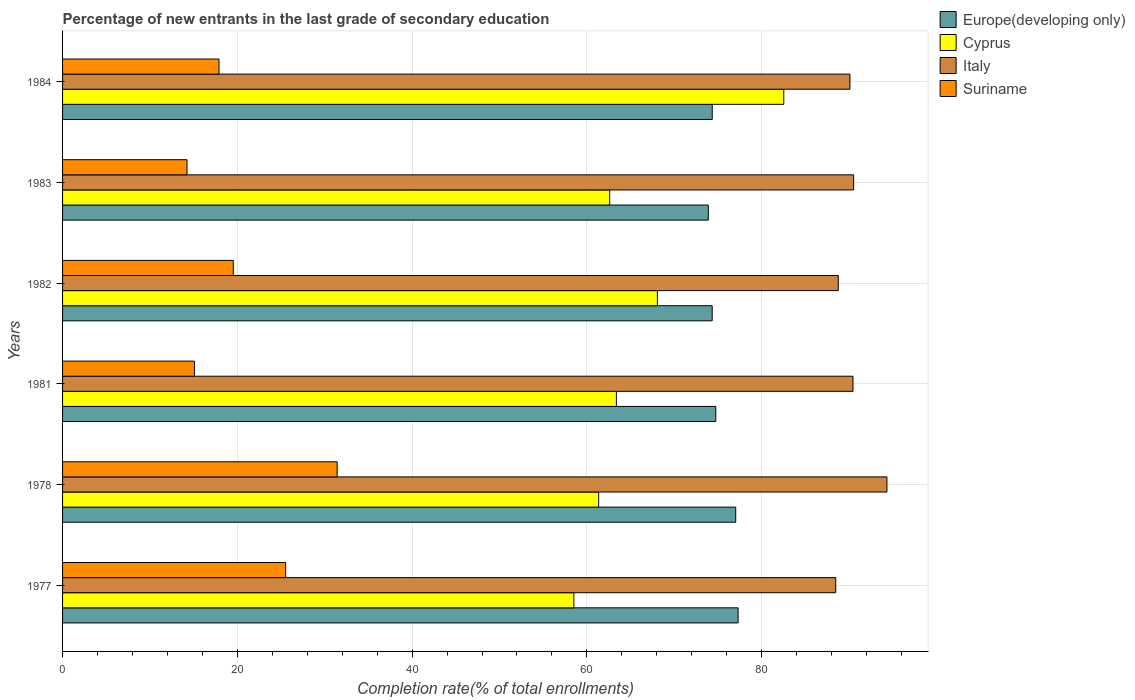How many groups of bars are there?
Make the answer very short. 6. How many bars are there on the 1st tick from the bottom?
Offer a terse response. 4. What is the label of the 1st group of bars from the top?
Keep it short and to the point. 1984. In how many cases, is the number of bars for a given year not equal to the number of legend labels?
Provide a succinct answer. 0. What is the percentage of new entrants in Cyprus in 1983?
Provide a short and direct response. 62.61. Across all years, what is the maximum percentage of new entrants in Italy?
Your answer should be compact. 94.33. Across all years, what is the minimum percentage of new entrants in Italy?
Keep it short and to the point. 88.47. In which year was the percentage of new entrants in Suriname maximum?
Offer a very short reply. 1978. What is the total percentage of new entrants in Suriname in the graph?
Provide a short and direct response. 123.72. What is the difference between the percentage of new entrants in Europe(developing only) in 1978 and that in 1984?
Give a very brief answer. 2.69. What is the difference between the percentage of new entrants in Cyprus in 1981 and the percentage of new entrants in Suriname in 1984?
Keep it short and to the point. 45.47. What is the average percentage of new entrants in Europe(developing only) per year?
Ensure brevity in your answer.  75.28. In the year 1978, what is the difference between the percentage of new entrants in Suriname and percentage of new entrants in Europe(developing only)?
Your response must be concise. -45.61. What is the ratio of the percentage of new entrants in Cyprus in 1983 to that in 1984?
Provide a succinct answer. 0.76. Is the difference between the percentage of new entrants in Suriname in 1978 and 1981 greater than the difference between the percentage of new entrants in Europe(developing only) in 1978 and 1981?
Ensure brevity in your answer.  Yes. What is the difference between the highest and the second highest percentage of new entrants in Europe(developing only)?
Offer a very short reply. 0.27. What is the difference between the highest and the lowest percentage of new entrants in Europe(developing only)?
Ensure brevity in your answer.  3.41. In how many years, is the percentage of new entrants in Italy greater than the average percentage of new entrants in Italy taken over all years?
Provide a succinct answer. 3. Is it the case that in every year, the sum of the percentage of new entrants in Suriname and percentage of new entrants in Cyprus is greater than the sum of percentage of new entrants in Europe(developing only) and percentage of new entrants in Italy?
Make the answer very short. No. What does the 2nd bar from the top in 1981 represents?
Give a very brief answer. Italy. What does the 2nd bar from the bottom in 1982 represents?
Your response must be concise. Cyprus. Is it the case that in every year, the sum of the percentage of new entrants in Italy and percentage of new entrants in Cyprus is greater than the percentage of new entrants in Europe(developing only)?
Your answer should be very brief. Yes. Are all the bars in the graph horizontal?
Offer a terse response. Yes. How many years are there in the graph?
Make the answer very short. 6. What is the difference between two consecutive major ticks on the X-axis?
Give a very brief answer. 20. How many legend labels are there?
Your response must be concise. 4. What is the title of the graph?
Make the answer very short. Percentage of new entrants in the last grade of secondary education. Does "Nicaragua" appear as one of the legend labels in the graph?
Offer a terse response. No. What is the label or title of the X-axis?
Give a very brief answer. Completion rate(% of total enrollments). What is the Completion rate(% of total enrollments) of Europe(developing only) in 1977?
Offer a very short reply. 77.3. What is the Completion rate(% of total enrollments) in Cyprus in 1977?
Give a very brief answer. 58.51. What is the Completion rate(% of total enrollments) in Italy in 1977?
Provide a short and direct response. 88.47. What is the Completion rate(% of total enrollments) of Suriname in 1977?
Your response must be concise. 25.53. What is the Completion rate(% of total enrollments) in Europe(developing only) in 1978?
Offer a very short reply. 77.03. What is the Completion rate(% of total enrollments) of Cyprus in 1978?
Your response must be concise. 61.35. What is the Completion rate(% of total enrollments) of Italy in 1978?
Your answer should be very brief. 94.33. What is the Completion rate(% of total enrollments) of Suriname in 1978?
Your response must be concise. 31.42. What is the Completion rate(% of total enrollments) of Europe(developing only) in 1981?
Your response must be concise. 74.75. What is the Completion rate(% of total enrollments) of Cyprus in 1981?
Make the answer very short. 63.38. What is the Completion rate(% of total enrollments) in Italy in 1981?
Provide a short and direct response. 90.45. What is the Completion rate(% of total enrollments) in Suriname in 1981?
Keep it short and to the point. 15.09. What is the Completion rate(% of total enrollments) in Europe(developing only) in 1982?
Your answer should be very brief. 74.34. What is the Completion rate(% of total enrollments) of Cyprus in 1982?
Make the answer very short. 68.07. What is the Completion rate(% of total enrollments) of Italy in 1982?
Provide a succinct answer. 88.76. What is the Completion rate(% of total enrollments) of Suriname in 1982?
Provide a short and direct response. 19.54. What is the Completion rate(% of total enrollments) in Europe(developing only) in 1983?
Your response must be concise. 73.89. What is the Completion rate(% of total enrollments) of Cyprus in 1983?
Your response must be concise. 62.61. What is the Completion rate(% of total enrollments) of Italy in 1983?
Provide a short and direct response. 90.52. What is the Completion rate(% of total enrollments) of Suriname in 1983?
Offer a terse response. 14.24. What is the Completion rate(% of total enrollments) in Europe(developing only) in 1984?
Keep it short and to the point. 74.34. What is the Completion rate(% of total enrollments) of Cyprus in 1984?
Provide a succinct answer. 82.53. What is the Completion rate(% of total enrollments) of Italy in 1984?
Offer a very short reply. 90.1. What is the Completion rate(% of total enrollments) of Suriname in 1984?
Offer a terse response. 17.9. Across all years, what is the maximum Completion rate(% of total enrollments) of Europe(developing only)?
Your response must be concise. 77.3. Across all years, what is the maximum Completion rate(% of total enrollments) in Cyprus?
Provide a succinct answer. 82.53. Across all years, what is the maximum Completion rate(% of total enrollments) in Italy?
Offer a very short reply. 94.33. Across all years, what is the maximum Completion rate(% of total enrollments) of Suriname?
Your answer should be very brief. 31.42. Across all years, what is the minimum Completion rate(% of total enrollments) in Europe(developing only)?
Ensure brevity in your answer.  73.89. Across all years, what is the minimum Completion rate(% of total enrollments) of Cyprus?
Your answer should be very brief. 58.51. Across all years, what is the minimum Completion rate(% of total enrollments) of Italy?
Provide a short and direct response. 88.47. Across all years, what is the minimum Completion rate(% of total enrollments) in Suriname?
Give a very brief answer. 14.24. What is the total Completion rate(% of total enrollments) of Europe(developing only) in the graph?
Give a very brief answer. 451.66. What is the total Completion rate(% of total enrollments) in Cyprus in the graph?
Ensure brevity in your answer.  396.43. What is the total Completion rate(% of total enrollments) in Italy in the graph?
Provide a succinct answer. 542.64. What is the total Completion rate(% of total enrollments) in Suriname in the graph?
Your answer should be compact. 123.72. What is the difference between the Completion rate(% of total enrollments) of Europe(developing only) in 1977 and that in 1978?
Offer a very short reply. 0.27. What is the difference between the Completion rate(% of total enrollments) of Cyprus in 1977 and that in 1978?
Your answer should be very brief. -2.84. What is the difference between the Completion rate(% of total enrollments) of Italy in 1977 and that in 1978?
Offer a terse response. -5.86. What is the difference between the Completion rate(% of total enrollments) of Suriname in 1977 and that in 1978?
Make the answer very short. -5.89. What is the difference between the Completion rate(% of total enrollments) in Europe(developing only) in 1977 and that in 1981?
Make the answer very short. 2.55. What is the difference between the Completion rate(% of total enrollments) of Cyprus in 1977 and that in 1981?
Provide a succinct answer. -4.87. What is the difference between the Completion rate(% of total enrollments) of Italy in 1977 and that in 1981?
Your answer should be very brief. -1.97. What is the difference between the Completion rate(% of total enrollments) of Suriname in 1977 and that in 1981?
Offer a terse response. 10.44. What is the difference between the Completion rate(% of total enrollments) in Europe(developing only) in 1977 and that in 1982?
Offer a very short reply. 2.97. What is the difference between the Completion rate(% of total enrollments) in Cyprus in 1977 and that in 1982?
Provide a succinct answer. -9.56. What is the difference between the Completion rate(% of total enrollments) of Italy in 1977 and that in 1982?
Ensure brevity in your answer.  -0.29. What is the difference between the Completion rate(% of total enrollments) in Suriname in 1977 and that in 1982?
Your answer should be very brief. 5.99. What is the difference between the Completion rate(% of total enrollments) in Europe(developing only) in 1977 and that in 1983?
Offer a terse response. 3.41. What is the difference between the Completion rate(% of total enrollments) in Cyprus in 1977 and that in 1983?
Your response must be concise. -4.1. What is the difference between the Completion rate(% of total enrollments) of Italy in 1977 and that in 1983?
Give a very brief answer. -2.05. What is the difference between the Completion rate(% of total enrollments) of Suriname in 1977 and that in 1983?
Provide a short and direct response. 11.29. What is the difference between the Completion rate(% of total enrollments) of Europe(developing only) in 1977 and that in 1984?
Provide a succinct answer. 2.96. What is the difference between the Completion rate(% of total enrollments) of Cyprus in 1977 and that in 1984?
Offer a terse response. -24.02. What is the difference between the Completion rate(% of total enrollments) of Italy in 1977 and that in 1984?
Give a very brief answer. -1.62. What is the difference between the Completion rate(% of total enrollments) of Suriname in 1977 and that in 1984?
Offer a very short reply. 7.63. What is the difference between the Completion rate(% of total enrollments) in Europe(developing only) in 1978 and that in 1981?
Make the answer very short. 2.28. What is the difference between the Completion rate(% of total enrollments) of Cyprus in 1978 and that in 1981?
Your answer should be compact. -2.03. What is the difference between the Completion rate(% of total enrollments) in Italy in 1978 and that in 1981?
Ensure brevity in your answer.  3.88. What is the difference between the Completion rate(% of total enrollments) in Suriname in 1978 and that in 1981?
Your answer should be very brief. 16.33. What is the difference between the Completion rate(% of total enrollments) in Europe(developing only) in 1978 and that in 1982?
Provide a succinct answer. 2.69. What is the difference between the Completion rate(% of total enrollments) in Cyprus in 1978 and that in 1982?
Your answer should be compact. -6.72. What is the difference between the Completion rate(% of total enrollments) in Italy in 1978 and that in 1982?
Give a very brief answer. 5.57. What is the difference between the Completion rate(% of total enrollments) in Suriname in 1978 and that in 1982?
Provide a succinct answer. 11.88. What is the difference between the Completion rate(% of total enrollments) of Europe(developing only) in 1978 and that in 1983?
Your answer should be compact. 3.14. What is the difference between the Completion rate(% of total enrollments) of Cyprus in 1978 and that in 1983?
Provide a succinct answer. -1.26. What is the difference between the Completion rate(% of total enrollments) of Italy in 1978 and that in 1983?
Provide a short and direct response. 3.81. What is the difference between the Completion rate(% of total enrollments) of Suriname in 1978 and that in 1983?
Provide a succinct answer. 17.18. What is the difference between the Completion rate(% of total enrollments) in Europe(developing only) in 1978 and that in 1984?
Give a very brief answer. 2.69. What is the difference between the Completion rate(% of total enrollments) of Cyprus in 1978 and that in 1984?
Offer a terse response. -21.18. What is the difference between the Completion rate(% of total enrollments) in Italy in 1978 and that in 1984?
Offer a very short reply. 4.23. What is the difference between the Completion rate(% of total enrollments) of Suriname in 1978 and that in 1984?
Make the answer very short. 13.52. What is the difference between the Completion rate(% of total enrollments) in Europe(developing only) in 1981 and that in 1982?
Provide a succinct answer. 0.41. What is the difference between the Completion rate(% of total enrollments) in Cyprus in 1981 and that in 1982?
Provide a short and direct response. -4.69. What is the difference between the Completion rate(% of total enrollments) in Italy in 1981 and that in 1982?
Your answer should be compact. 1.68. What is the difference between the Completion rate(% of total enrollments) in Suriname in 1981 and that in 1982?
Make the answer very short. -4.45. What is the difference between the Completion rate(% of total enrollments) in Europe(developing only) in 1981 and that in 1983?
Ensure brevity in your answer.  0.86. What is the difference between the Completion rate(% of total enrollments) of Cyprus in 1981 and that in 1983?
Ensure brevity in your answer.  0.77. What is the difference between the Completion rate(% of total enrollments) of Italy in 1981 and that in 1983?
Ensure brevity in your answer.  -0.07. What is the difference between the Completion rate(% of total enrollments) of Suriname in 1981 and that in 1983?
Offer a terse response. 0.85. What is the difference between the Completion rate(% of total enrollments) in Europe(developing only) in 1981 and that in 1984?
Make the answer very short. 0.41. What is the difference between the Completion rate(% of total enrollments) in Cyprus in 1981 and that in 1984?
Offer a very short reply. -19.16. What is the difference between the Completion rate(% of total enrollments) in Italy in 1981 and that in 1984?
Offer a very short reply. 0.35. What is the difference between the Completion rate(% of total enrollments) of Suriname in 1981 and that in 1984?
Ensure brevity in your answer.  -2.81. What is the difference between the Completion rate(% of total enrollments) in Europe(developing only) in 1982 and that in 1983?
Give a very brief answer. 0.44. What is the difference between the Completion rate(% of total enrollments) in Cyprus in 1982 and that in 1983?
Offer a terse response. 5.46. What is the difference between the Completion rate(% of total enrollments) in Italy in 1982 and that in 1983?
Your answer should be very brief. -1.76. What is the difference between the Completion rate(% of total enrollments) of Suriname in 1982 and that in 1983?
Give a very brief answer. 5.3. What is the difference between the Completion rate(% of total enrollments) in Europe(developing only) in 1982 and that in 1984?
Ensure brevity in your answer.  -0.01. What is the difference between the Completion rate(% of total enrollments) of Cyprus in 1982 and that in 1984?
Your response must be concise. -14.46. What is the difference between the Completion rate(% of total enrollments) in Italy in 1982 and that in 1984?
Provide a succinct answer. -1.33. What is the difference between the Completion rate(% of total enrollments) in Suriname in 1982 and that in 1984?
Provide a short and direct response. 1.64. What is the difference between the Completion rate(% of total enrollments) of Europe(developing only) in 1983 and that in 1984?
Provide a succinct answer. -0.45. What is the difference between the Completion rate(% of total enrollments) of Cyprus in 1983 and that in 1984?
Give a very brief answer. -19.92. What is the difference between the Completion rate(% of total enrollments) in Italy in 1983 and that in 1984?
Make the answer very short. 0.42. What is the difference between the Completion rate(% of total enrollments) in Suriname in 1983 and that in 1984?
Your answer should be very brief. -3.66. What is the difference between the Completion rate(% of total enrollments) of Europe(developing only) in 1977 and the Completion rate(% of total enrollments) of Cyprus in 1978?
Provide a succinct answer. 15.96. What is the difference between the Completion rate(% of total enrollments) of Europe(developing only) in 1977 and the Completion rate(% of total enrollments) of Italy in 1978?
Make the answer very short. -17.03. What is the difference between the Completion rate(% of total enrollments) in Europe(developing only) in 1977 and the Completion rate(% of total enrollments) in Suriname in 1978?
Your response must be concise. 45.88. What is the difference between the Completion rate(% of total enrollments) in Cyprus in 1977 and the Completion rate(% of total enrollments) in Italy in 1978?
Your answer should be very brief. -35.82. What is the difference between the Completion rate(% of total enrollments) in Cyprus in 1977 and the Completion rate(% of total enrollments) in Suriname in 1978?
Offer a very short reply. 27.09. What is the difference between the Completion rate(% of total enrollments) in Italy in 1977 and the Completion rate(% of total enrollments) in Suriname in 1978?
Provide a short and direct response. 57.05. What is the difference between the Completion rate(% of total enrollments) of Europe(developing only) in 1977 and the Completion rate(% of total enrollments) of Cyprus in 1981?
Your response must be concise. 13.93. What is the difference between the Completion rate(% of total enrollments) in Europe(developing only) in 1977 and the Completion rate(% of total enrollments) in Italy in 1981?
Make the answer very short. -13.15. What is the difference between the Completion rate(% of total enrollments) in Europe(developing only) in 1977 and the Completion rate(% of total enrollments) in Suriname in 1981?
Provide a succinct answer. 62.21. What is the difference between the Completion rate(% of total enrollments) of Cyprus in 1977 and the Completion rate(% of total enrollments) of Italy in 1981?
Your answer should be compact. -31.94. What is the difference between the Completion rate(% of total enrollments) of Cyprus in 1977 and the Completion rate(% of total enrollments) of Suriname in 1981?
Offer a very short reply. 43.42. What is the difference between the Completion rate(% of total enrollments) of Italy in 1977 and the Completion rate(% of total enrollments) of Suriname in 1981?
Your answer should be compact. 73.39. What is the difference between the Completion rate(% of total enrollments) in Europe(developing only) in 1977 and the Completion rate(% of total enrollments) in Cyprus in 1982?
Your response must be concise. 9.24. What is the difference between the Completion rate(% of total enrollments) in Europe(developing only) in 1977 and the Completion rate(% of total enrollments) in Italy in 1982?
Offer a terse response. -11.46. What is the difference between the Completion rate(% of total enrollments) of Europe(developing only) in 1977 and the Completion rate(% of total enrollments) of Suriname in 1982?
Ensure brevity in your answer.  57.76. What is the difference between the Completion rate(% of total enrollments) in Cyprus in 1977 and the Completion rate(% of total enrollments) in Italy in 1982?
Offer a very short reply. -30.26. What is the difference between the Completion rate(% of total enrollments) in Cyprus in 1977 and the Completion rate(% of total enrollments) in Suriname in 1982?
Provide a succinct answer. 38.97. What is the difference between the Completion rate(% of total enrollments) of Italy in 1977 and the Completion rate(% of total enrollments) of Suriname in 1982?
Ensure brevity in your answer.  68.94. What is the difference between the Completion rate(% of total enrollments) in Europe(developing only) in 1977 and the Completion rate(% of total enrollments) in Cyprus in 1983?
Make the answer very short. 14.69. What is the difference between the Completion rate(% of total enrollments) in Europe(developing only) in 1977 and the Completion rate(% of total enrollments) in Italy in 1983?
Your answer should be compact. -13.22. What is the difference between the Completion rate(% of total enrollments) of Europe(developing only) in 1977 and the Completion rate(% of total enrollments) of Suriname in 1983?
Give a very brief answer. 63.06. What is the difference between the Completion rate(% of total enrollments) of Cyprus in 1977 and the Completion rate(% of total enrollments) of Italy in 1983?
Your answer should be very brief. -32.02. What is the difference between the Completion rate(% of total enrollments) of Cyprus in 1977 and the Completion rate(% of total enrollments) of Suriname in 1983?
Offer a terse response. 44.27. What is the difference between the Completion rate(% of total enrollments) in Italy in 1977 and the Completion rate(% of total enrollments) in Suriname in 1983?
Your answer should be very brief. 74.23. What is the difference between the Completion rate(% of total enrollments) in Europe(developing only) in 1977 and the Completion rate(% of total enrollments) in Cyprus in 1984?
Your answer should be very brief. -5.23. What is the difference between the Completion rate(% of total enrollments) of Europe(developing only) in 1977 and the Completion rate(% of total enrollments) of Italy in 1984?
Make the answer very short. -12.8. What is the difference between the Completion rate(% of total enrollments) in Europe(developing only) in 1977 and the Completion rate(% of total enrollments) in Suriname in 1984?
Offer a very short reply. 59.4. What is the difference between the Completion rate(% of total enrollments) in Cyprus in 1977 and the Completion rate(% of total enrollments) in Italy in 1984?
Provide a short and direct response. -31.59. What is the difference between the Completion rate(% of total enrollments) of Cyprus in 1977 and the Completion rate(% of total enrollments) of Suriname in 1984?
Give a very brief answer. 40.61. What is the difference between the Completion rate(% of total enrollments) of Italy in 1977 and the Completion rate(% of total enrollments) of Suriname in 1984?
Offer a terse response. 70.57. What is the difference between the Completion rate(% of total enrollments) in Europe(developing only) in 1978 and the Completion rate(% of total enrollments) in Cyprus in 1981?
Keep it short and to the point. 13.66. What is the difference between the Completion rate(% of total enrollments) of Europe(developing only) in 1978 and the Completion rate(% of total enrollments) of Italy in 1981?
Offer a very short reply. -13.42. What is the difference between the Completion rate(% of total enrollments) in Europe(developing only) in 1978 and the Completion rate(% of total enrollments) in Suriname in 1981?
Offer a terse response. 61.94. What is the difference between the Completion rate(% of total enrollments) in Cyprus in 1978 and the Completion rate(% of total enrollments) in Italy in 1981?
Provide a succinct answer. -29.1. What is the difference between the Completion rate(% of total enrollments) in Cyprus in 1978 and the Completion rate(% of total enrollments) in Suriname in 1981?
Your answer should be very brief. 46.26. What is the difference between the Completion rate(% of total enrollments) of Italy in 1978 and the Completion rate(% of total enrollments) of Suriname in 1981?
Your answer should be very brief. 79.24. What is the difference between the Completion rate(% of total enrollments) in Europe(developing only) in 1978 and the Completion rate(% of total enrollments) in Cyprus in 1982?
Provide a short and direct response. 8.96. What is the difference between the Completion rate(% of total enrollments) of Europe(developing only) in 1978 and the Completion rate(% of total enrollments) of Italy in 1982?
Provide a short and direct response. -11.73. What is the difference between the Completion rate(% of total enrollments) in Europe(developing only) in 1978 and the Completion rate(% of total enrollments) in Suriname in 1982?
Provide a short and direct response. 57.49. What is the difference between the Completion rate(% of total enrollments) of Cyprus in 1978 and the Completion rate(% of total enrollments) of Italy in 1982?
Provide a succinct answer. -27.42. What is the difference between the Completion rate(% of total enrollments) in Cyprus in 1978 and the Completion rate(% of total enrollments) in Suriname in 1982?
Keep it short and to the point. 41.81. What is the difference between the Completion rate(% of total enrollments) in Italy in 1978 and the Completion rate(% of total enrollments) in Suriname in 1982?
Make the answer very short. 74.79. What is the difference between the Completion rate(% of total enrollments) in Europe(developing only) in 1978 and the Completion rate(% of total enrollments) in Cyprus in 1983?
Ensure brevity in your answer.  14.42. What is the difference between the Completion rate(% of total enrollments) in Europe(developing only) in 1978 and the Completion rate(% of total enrollments) in Italy in 1983?
Provide a short and direct response. -13.49. What is the difference between the Completion rate(% of total enrollments) of Europe(developing only) in 1978 and the Completion rate(% of total enrollments) of Suriname in 1983?
Ensure brevity in your answer.  62.79. What is the difference between the Completion rate(% of total enrollments) of Cyprus in 1978 and the Completion rate(% of total enrollments) of Italy in 1983?
Keep it short and to the point. -29.18. What is the difference between the Completion rate(% of total enrollments) in Cyprus in 1978 and the Completion rate(% of total enrollments) in Suriname in 1983?
Your answer should be very brief. 47.1. What is the difference between the Completion rate(% of total enrollments) of Italy in 1978 and the Completion rate(% of total enrollments) of Suriname in 1983?
Your answer should be very brief. 80.09. What is the difference between the Completion rate(% of total enrollments) of Europe(developing only) in 1978 and the Completion rate(% of total enrollments) of Cyprus in 1984?
Give a very brief answer. -5.5. What is the difference between the Completion rate(% of total enrollments) of Europe(developing only) in 1978 and the Completion rate(% of total enrollments) of Italy in 1984?
Your answer should be very brief. -13.07. What is the difference between the Completion rate(% of total enrollments) of Europe(developing only) in 1978 and the Completion rate(% of total enrollments) of Suriname in 1984?
Give a very brief answer. 59.13. What is the difference between the Completion rate(% of total enrollments) in Cyprus in 1978 and the Completion rate(% of total enrollments) in Italy in 1984?
Provide a succinct answer. -28.75. What is the difference between the Completion rate(% of total enrollments) of Cyprus in 1978 and the Completion rate(% of total enrollments) of Suriname in 1984?
Make the answer very short. 43.44. What is the difference between the Completion rate(% of total enrollments) of Italy in 1978 and the Completion rate(% of total enrollments) of Suriname in 1984?
Your answer should be compact. 76.43. What is the difference between the Completion rate(% of total enrollments) of Europe(developing only) in 1981 and the Completion rate(% of total enrollments) of Cyprus in 1982?
Give a very brief answer. 6.68. What is the difference between the Completion rate(% of total enrollments) in Europe(developing only) in 1981 and the Completion rate(% of total enrollments) in Italy in 1982?
Give a very brief answer. -14.01. What is the difference between the Completion rate(% of total enrollments) in Europe(developing only) in 1981 and the Completion rate(% of total enrollments) in Suriname in 1982?
Offer a very short reply. 55.21. What is the difference between the Completion rate(% of total enrollments) of Cyprus in 1981 and the Completion rate(% of total enrollments) of Italy in 1982?
Provide a short and direct response. -25.39. What is the difference between the Completion rate(% of total enrollments) of Cyprus in 1981 and the Completion rate(% of total enrollments) of Suriname in 1982?
Your answer should be compact. 43.84. What is the difference between the Completion rate(% of total enrollments) of Italy in 1981 and the Completion rate(% of total enrollments) of Suriname in 1982?
Provide a short and direct response. 70.91. What is the difference between the Completion rate(% of total enrollments) in Europe(developing only) in 1981 and the Completion rate(% of total enrollments) in Cyprus in 1983?
Provide a succinct answer. 12.14. What is the difference between the Completion rate(% of total enrollments) of Europe(developing only) in 1981 and the Completion rate(% of total enrollments) of Italy in 1983?
Provide a short and direct response. -15.77. What is the difference between the Completion rate(% of total enrollments) in Europe(developing only) in 1981 and the Completion rate(% of total enrollments) in Suriname in 1983?
Provide a succinct answer. 60.51. What is the difference between the Completion rate(% of total enrollments) in Cyprus in 1981 and the Completion rate(% of total enrollments) in Italy in 1983?
Provide a short and direct response. -27.15. What is the difference between the Completion rate(% of total enrollments) in Cyprus in 1981 and the Completion rate(% of total enrollments) in Suriname in 1983?
Keep it short and to the point. 49.13. What is the difference between the Completion rate(% of total enrollments) in Italy in 1981 and the Completion rate(% of total enrollments) in Suriname in 1983?
Ensure brevity in your answer.  76.21. What is the difference between the Completion rate(% of total enrollments) in Europe(developing only) in 1981 and the Completion rate(% of total enrollments) in Cyprus in 1984?
Make the answer very short. -7.78. What is the difference between the Completion rate(% of total enrollments) in Europe(developing only) in 1981 and the Completion rate(% of total enrollments) in Italy in 1984?
Your response must be concise. -15.35. What is the difference between the Completion rate(% of total enrollments) in Europe(developing only) in 1981 and the Completion rate(% of total enrollments) in Suriname in 1984?
Your answer should be very brief. 56.85. What is the difference between the Completion rate(% of total enrollments) of Cyprus in 1981 and the Completion rate(% of total enrollments) of Italy in 1984?
Provide a succinct answer. -26.72. What is the difference between the Completion rate(% of total enrollments) of Cyprus in 1981 and the Completion rate(% of total enrollments) of Suriname in 1984?
Your answer should be very brief. 45.47. What is the difference between the Completion rate(% of total enrollments) in Italy in 1981 and the Completion rate(% of total enrollments) in Suriname in 1984?
Provide a succinct answer. 72.55. What is the difference between the Completion rate(% of total enrollments) of Europe(developing only) in 1982 and the Completion rate(% of total enrollments) of Cyprus in 1983?
Make the answer very short. 11.73. What is the difference between the Completion rate(% of total enrollments) of Europe(developing only) in 1982 and the Completion rate(% of total enrollments) of Italy in 1983?
Offer a very short reply. -16.19. What is the difference between the Completion rate(% of total enrollments) of Europe(developing only) in 1982 and the Completion rate(% of total enrollments) of Suriname in 1983?
Offer a terse response. 60.09. What is the difference between the Completion rate(% of total enrollments) in Cyprus in 1982 and the Completion rate(% of total enrollments) in Italy in 1983?
Provide a short and direct response. -22.46. What is the difference between the Completion rate(% of total enrollments) of Cyprus in 1982 and the Completion rate(% of total enrollments) of Suriname in 1983?
Make the answer very short. 53.82. What is the difference between the Completion rate(% of total enrollments) of Italy in 1982 and the Completion rate(% of total enrollments) of Suriname in 1983?
Provide a short and direct response. 74.52. What is the difference between the Completion rate(% of total enrollments) of Europe(developing only) in 1982 and the Completion rate(% of total enrollments) of Cyprus in 1984?
Your answer should be very brief. -8.19. What is the difference between the Completion rate(% of total enrollments) in Europe(developing only) in 1982 and the Completion rate(% of total enrollments) in Italy in 1984?
Ensure brevity in your answer.  -15.76. What is the difference between the Completion rate(% of total enrollments) in Europe(developing only) in 1982 and the Completion rate(% of total enrollments) in Suriname in 1984?
Your response must be concise. 56.43. What is the difference between the Completion rate(% of total enrollments) of Cyprus in 1982 and the Completion rate(% of total enrollments) of Italy in 1984?
Your response must be concise. -22.03. What is the difference between the Completion rate(% of total enrollments) of Cyprus in 1982 and the Completion rate(% of total enrollments) of Suriname in 1984?
Offer a terse response. 50.16. What is the difference between the Completion rate(% of total enrollments) in Italy in 1982 and the Completion rate(% of total enrollments) in Suriname in 1984?
Make the answer very short. 70.86. What is the difference between the Completion rate(% of total enrollments) of Europe(developing only) in 1983 and the Completion rate(% of total enrollments) of Cyprus in 1984?
Ensure brevity in your answer.  -8.64. What is the difference between the Completion rate(% of total enrollments) in Europe(developing only) in 1983 and the Completion rate(% of total enrollments) in Italy in 1984?
Your response must be concise. -16.21. What is the difference between the Completion rate(% of total enrollments) in Europe(developing only) in 1983 and the Completion rate(% of total enrollments) in Suriname in 1984?
Your response must be concise. 55.99. What is the difference between the Completion rate(% of total enrollments) in Cyprus in 1983 and the Completion rate(% of total enrollments) in Italy in 1984?
Keep it short and to the point. -27.49. What is the difference between the Completion rate(% of total enrollments) of Cyprus in 1983 and the Completion rate(% of total enrollments) of Suriname in 1984?
Your response must be concise. 44.71. What is the difference between the Completion rate(% of total enrollments) of Italy in 1983 and the Completion rate(% of total enrollments) of Suriname in 1984?
Your answer should be very brief. 72.62. What is the average Completion rate(% of total enrollments) of Europe(developing only) per year?
Your answer should be very brief. 75.28. What is the average Completion rate(% of total enrollments) of Cyprus per year?
Give a very brief answer. 66.07. What is the average Completion rate(% of total enrollments) of Italy per year?
Make the answer very short. 90.44. What is the average Completion rate(% of total enrollments) in Suriname per year?
Your response must be concise. 20.62. In the year 1977, what is the difference between the Completion rate(% of total enrollments) of Europe(developing only) and Completion rate(% of total enrollments) of Cyprus?
Give a very brief answer. 18.79. In the year 1977, what is the difference between the Completion rate(% of total enrollments) in Europe(developing only) and Completion rate(% of total enrollments) in Italy?
Ensure brevity in your answer.  -11.17. In the year 1977, what is the difference between the Completion rate(% of total enrollments) in Europe(developing only) and Completion rate(% of total enrollments) in Suriname?
Your response must be concise. 51.77. In the year 1977, what is the difference between the Completion rate(% of total enrollments) in Cyprus and Completion rate(% of total enrollments) in Italy?
Make the answer very short. -29.97. In the year 1977, what is the difference between the Completion rate(% of total enrollments) in Cyprus and Completion rate(% of total enrollments) in Suriname?
Offer a very short reply. 32.98. In the year 1977, what is the difference between the Completion rate(% of total enrollments) of Italy and Completion rate(% of total enrollments) of Suriname?
Offer a terse response. 62.95. In the year 1978, what is the difference between the Completion rate(% of total enrollments) in Europe(developing only) and Completion rate(% of total enrollments) in Cyprus?
Make the answer very short. 15.69. In the year 1978, what is the difference between the Completion rate(% of total enrollments) of Europe(developing only) and Completion rate(% of total enrollments) of Italy?
Your response must be concise. -17.3. In the year 1978, what is the difference between the Completion rate(% of total enrollments) in Europe(developing only) and Completion rate(% of total enrollments) in Suriname?
Give a very brief answer. 45.61. In the year 1978, what is the difference between the Completion rate(% of total enrollments) of Cyprus and Completion rate(% of total enrollments) of Italy?
Keep it short and to the point. -32.99. In the year 1978, what is the difference between the Completion rate(% of total enrollments) in Cyprus and Completion rate(% of total enrollments) in Suriname?
Keep it short and to the point. 29.92. In the year 1978, what is the difference between the Completion rate(% of total enrollments) of Italy and Completion rate(% of total enrollments) of Suriname?
Offer a very short reply. 62.91. In the year 1981, what is the difference between the Completion rate(% of total enrollments) in Europe(developing only) and Completion rate(% of total enrollments) in Cyprus?
Provide a short and direct response. 11.38. In the year 1981, what is the difference between the Completion rate(% of total enrollments) of Europe(developing only) and Completion rate(% of total enrollments) of Italy?
Make the answer very short. -15.7. In the year 1981, what is the difference between the Completion rate(% of total enrollments) of Europe(developing only) and Completion rate(% of total enrollments) of Suriname?
Make the answer very short. 59.66. In the year 1981, what is the difference between the Completion rate(% of total enrollments) in Cyprus and Completion rate(% of total enrollments) in Italy?
Your response must be concise. -27.07. In the year 1981, what is the difference between the Completion rate(% of total enrollments) of Cyprus and Completion rate(% of total enrollments) of Suriname?
Provide a succinct answer. 48.29. In the year 1981, what is the difference between the Completion rate(% of total enrollments) in Italy and Completion rate(% of total enrollments) in Suriname?
Provide a short and direct response. 75.36. In the year 1982, what is the difference between the Completion rate(% of total enrollments) of Europe(developing only) and Completion rate(% of total enrollments) of Cyprus?
Your response must be concise. 6.27. In the year 1982, what is the difference between the Completion rate(% of total enrollments) of Europe(developing only) and Completion rate(% of total enrollments) of Italy?
Give a very brief answer. -14.43. In the year 1982, what is the difference between the Completion rate(% of total enrollments) in Europe(developing only) and Completion rate(% of total enrollments) in Suriname?
Your answer should be very brief. 54.8. In the year 1982, what is the difference between the Completion rate(% of total enrollments) of Cyprus and Completion rate(% of total enrollments) of Italy?
Make the answer very short. -20.7. In the year 1982, what is the difference between the Completion rate(% of total enrollments) in Cyprus and Completion rate(% of total enrollments) in Suriname?
Your response must be concise. 48.53. In the year 1982, what is the difference between the Completion rate(% of total enrollments) of Italy and Completion rate(% of total enrollments) of Suriname?
Provide a short and direct response. 69.23. In the year 1983, what is the difference between the Completion rate(% of total enrollments) in Europe(developing only) and Completion rate(% of total enrollments) in Cyprus?
Offer a very short reply. 11.28. In the year 1983, what is the difference between the Completion rate(% of total enrollments) in Europe(developing only) and Completion rate(% of total enrollments) in Italy?
Your response must be concise. -16.63. In the year 1983, what is the difference between the Completion rate(% of total enrollments) in Europe(developing only) and Completion rate(% of total enrollments) in Suriname?
Your answer should be compact. 59.65. In the year 1983, what is the difference between the Completion rate(% of total enrollments) of Cyprus and Completion rate(% of total enrollments) of Italy?
Offer a very short reply. -27.91. In the year 1983, what is the difference between the Completion rate(% of total enrollments) in Cyprus and Completion rate(% of total enrollments) in Suriname?
Offer a terse response. 48.37. In the year 1983, what is the difference between the Completion rate(% of total enrollments) of Italy and Completion rate(% of total enrollments) of Suriname?
Offer a terse response. 76.28. In the year 1984, what is the difference between the Completion rate(% of total enrollments) in Europe(developing only) and Completion rate(% of total enrollments) in Cyprus?
Provide a succinct answer. -8.19. In the year 1984, what is the difference between the Completion rate(% of total enrollments) of Europe(developing only) and Completion rate(% of total enrollments) of Italy?
Provide a short and direct response. -15.76. In the year 1984, what is the difference between the Completion rate(% of total enrollments) in Europe(developing only) and Completion rate(% of total enrollments) in Suriname?
Offer a terse response. 56.44. In the year 1984, what is the difference between the Completion rate(% of total enrollments) in Cyprus and Completion rate(% of total enrollments) in Italy?
Make the answer very short. -7.57. In the year 1984, what is the difference between the Completion rate(% of total enrollments) of Cyprus and Completion rate(% of total enrollments) of Suriname?
Offer a terse response. 64.63. In the year 1984, what is the difference between the Completion rate(% of total enrollments) in Italy and Completion rate(% of total enrollments) in Suriname?
Ensure brevity in your answer.  72.2. What is the ratio of the Completion rate(% of total enrollments) in Europe(developing only) in 1977 to that in 1978?
Provide a short and direct response. 1. What is the ratio of the Completion rate(% of total enrollments) of Cyprus in 1977 to that in 1978?
Your response must be concise. 0.95. What is the ratio of the Completion rate(% of total enrollments) in Italy in 1977 to that in 1978?
Provide a succinct answer. 0.94. What is the ratio of the Completion rate(% of total enrollments) in Suriname in 1977 to that in 1978?
Provide a succinct answer. 0.81. What is the ratio of the Completion rate(% of total enrollments) of Europe(developing only) in 1977 to that in 1981?
Make the answer very short. 1.03. What is the ratio of the Completion rate(% of total enrollments) of Cyprus in 1977 to that in 1981?
Your response must be concise. 0.92. What is the ratio of the Completion rate(% of total enrollments) in Italy in 1977 to that in 1981?
Provide a short and direct response. 0.98. What is the ratio of the Completion rate(% of total enrollments) of Suriname in 1977 to that in 1981?
Provide a short and direct response. 1.69. What is the ratio of the Completion rate(% of total enrollments) of Europe(developing only) in 1977 to that in 1982?
Your response must be concise. 1.04. What is the ratio of the Completion rate(% of total enrollments) of Cyprus in 1977 to that in 1982?
Ensure brevity in your answer.  0.86. What is the ratio of the Completion rate(% of total enrollments) of Suriname in 1977 to that in 1982?
Your answer should be very brief. 1.31. What is the ratio of the Completion rate(% of total enrollments) of Europe(developing only) in 1977 to that in 1983?
Offer a very short reply. 1.05. What is the ratio of the Completion rate(% of total enrollments) in Cyprus in 1977 to that in 1983?
Your answer should be very brief. 0.93. What is the ratio of the Completion rate(% of total enrollments) of Italy in 1977 to that in 1983?
Give a very brief answer. 0.98. What is the ratio of the Completion rate(% of total enrollments) in Suriname in 1977 to that in 1983?
Give a very brief answer. 1.79. What is the ratio of the Completion rate(% of total enrollments) of Europe(developing only) in 1977 to that in 1984?
Your answer should be very brief. 1.04. What is the ratio of the Completion rate(% of total enrollments) of Cyprus in 1977 to that in 1984?
Offer a very short reply. 0.71. What is the ratio of the Completion rate(% of total enrollments) of Suriname in 1977 to that in 1984?
Provide a succinct answer. 1.43. What is the ratio of the Completion rate(% of total enrollments) of Europe(developing only) in 1978 to that in 1981?
Provide a succinct answer. 1.03. What is the ratio of the Completion rate(% of total enrollments) of Cyprus in 1978 to that in 1981?
Give a very brief answer. 0.97. What is the ratio of the Completion rate(% of total enrollments) of Italy in 1978 to that in 1981?
Make the answer very short. 1.04. What is the ratio of the Completion rate(% of total enrollments) in Suriname in 1978 to that in 1981?
Ensure brevity in your answer.  2.08. What is the ratio of the Completion rate(% of total enrollments) of Europe(developing only) in 1978 to that in 1982?
Offer a very short reply. 1.04. What is the ratio of the Completion rate(% of total enrollments) of Cyprus in 1978 to that in 1982?
Ensure brevity in your answer.  0.9. What is the ratio of the Completion rate(% of total enrollments) in Italy in 1978 to that in 1982?
Your answer should be compact. 1.06. What is the ratio of the Completion rate(% of total enrollments) in Suriname in 1978 to that in 1982?
Provide a succinct answer. 1.61. What is the ratio of the Completion rate(% of total enrollments) of Europe(developing only) in 1978 to that in 1983?
Provide a short and direct response. 1.04. What is the ratio of the Completion rate(% of total enrollments) of Cyprus in 1978 to that in 1983?
Provide a succinct answer. 0.98. What is the ratio of the Completion rate(% of total enrollments) in Italy in 1978 to that in 1983?
Your answer should be compact. 1.04. What is the ratio of the Completion rate(% of total enrollments) of Suriname in 1978 to that in 1983?
Make the answer very short. 2.21. What is the ratio of the Completion rate(% of total enrollments) of Europe(developing only) in 1978 to that in 1984?
Your answer should be compact. 1.04. What is the ratio of the Completion rate(% of total enrollments) of Cyprus in 1978 to that in 1984?
Provide a succinct answer. 0.74. What is the ratio of the Completion rate(% of total enrollments) of Italy in 1978 to that in 1984?
Provide a succinct answer. 1.05. What is the ratio of the Completion rate(% of total enrollments) of Suriname in 1978 to that in 1984?
Offer a terse response. 1.76. What is the ratio of the Completion rate(% of total enrollments) in Europe(developing only) in 1981 to that in 1982?
Make the answer very short. 1.01. What is the ratio of the Completion rate(% of total enrollments) of Cyprus in 1981 to that in 1982?
Your answer should be very brief. 0.93. What is the ratio of the Completion rate(% of total enrollments) in Italy in 1981 to that in 1982?
Your answer should be very brief. 1.02. What is the ratio of the Completion rate(% of total enrollments) of Suriname in 1981 to that in 1982?
Your answer should be very brief. 0.77. What is the ratio of the Completion rate(% of total enrollments) in Europe(developing only) in 1981 to that in 1983?
Your answer should be very brief. 1.01. What is the ratio of the Completion rate(% of total enrollments) of Cyprus in 1981 to that in 1983?
Give a very brief answer. 1.01. What is the ratio of the Completion rate(% of total enrollments) of Italy in 1981 to that in 1983?
Offer a terse response. 1. What is the ratio of the Completion rate(% of total enrollments) of Suriname in 1981 to that in 1983?
Your answer should be very brief. 1.06. What is the ratio of the Completion rate(% of total enrollments) of Europe(developing only) in 1981 to that in 1984?
Offer a terse response. 1.01. What is the ratio of the Completion rate(% of total enrollments) in Cyprus in 1981 to that in 1984?
Make the answer very short. 0.77. What is the ratio of the Completion rate(% of total enrollments) of Suriname in 1981 to that in 1984?
Give a very brief answer. 0.84. What is the ratio of the Completion rate(% of total enrollments) in Europe(developing only) in 1982 to that in 1983?
Offer a very short reply. 1.01. What is the ratio of the Completion rate(% of total enrollments) of Cyprus in 1982 to that in 1983?
Give a very brief answer. 1.09. What is the ratio of the Completion rate(% of total enrollments) in Italy in 1982 to that in 1983?
Your answer should be very brief. 0.98. What is the ratio of the Completion rate(% of total enrollments) of Suriname in 1982 to that in 1983?
Your answer should be compact. 1.37. What is the ratio of the Completion rate(% of total enrollments) in Europe(developing only) in 1982 to that in 1984?
Make the answer very short. 1. What is the ratio of the Completion rate(% of total enrollments) in Cyprus in 1982 to that in 1984?
Provide a short and direct response. 0.82. What is the ratio of the Completion rate(% of total enrollments) in Italy in 1982 to that in 1984?
Provide a succinct answer. 0.99. What is the ratio of the Completion rate(% of total enrollments) of Suriname in 1982 to that in 1984?
Your response must be concise. 1.09. What is the ratio of the Completion rate(% of total enrollments) in Cyprus in 1983 to that in 1984?
Your answer should be very brief. 0.76. What is the ratio of the Completion rate(% of total enrollments) of Italy in 1983 to that in 1984?
Ensure brevity in your answer.  1. What is the ratio of the Completion rate(% of total enrollments) in Suriname in 1983 to that in 1984?
Give a very brief answer. 0.8. What is the difference between the highest and the second highest Completion rate(% of total enrollments) of Europe(developing only)?
Provide a short and direct response. 0.27. What is the difference between the highest and the second highest Completion rate(% of total enrollments) of Cyprus?
Ensure brevity in your answer.  14.46. What is the difference between the highest and the second highest Completion rate(% of total enrollments) in Italy?
Give a very brief answer. 3.81. What is the difference between the highest and the second highest Completion rate(% of total enrollments) of Suriname?
Offer a very short reply. 5.89. What is the difference between the highest and the lowest Completion rate(% of total enrollments) of Europe(developing only)?
Your answer should be very brief. 3.41. What is the difference between the highest and the lowest Completion rate(% of total enrollments) in Cyprus?
Make the answer very short. 24.02. What is the difference between the highest and the lowest Completion rate(% of total enrollments) of Italy?
Make the answer very short. 5.86. What is the difference between the highest and the lowest Completion rate(% of total enrollments) of Suriname?
Make the answer very short. 17.18. 